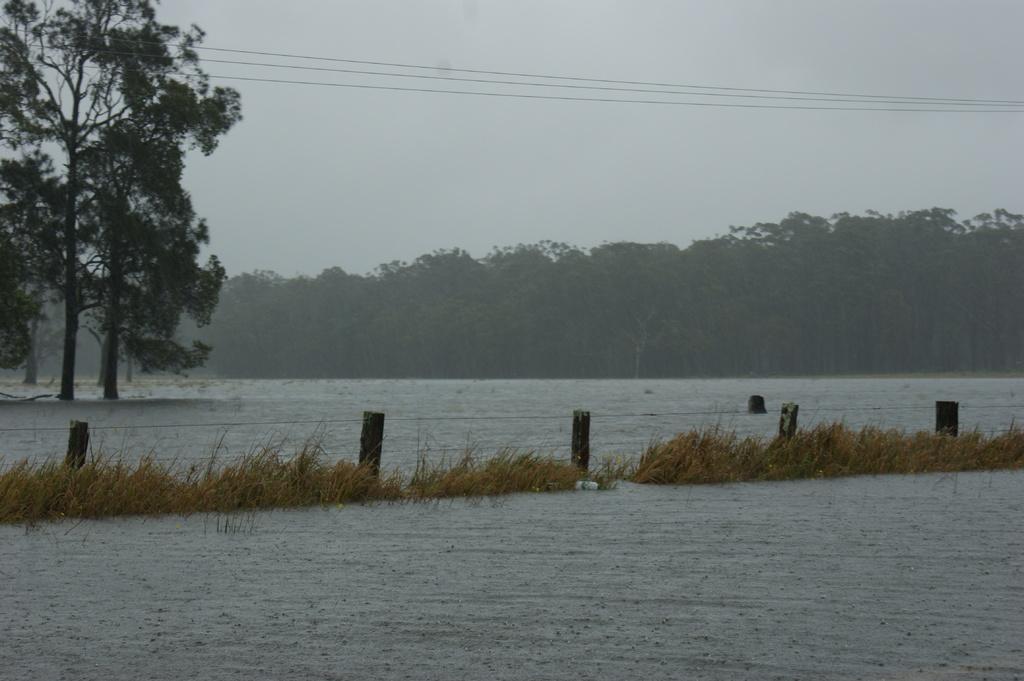Describe this image in one or two sentences. In this image in the front there is water. In the center there is grass and there is fence. In the background there are trees and the sky is cloudy and there are wires at the top. 